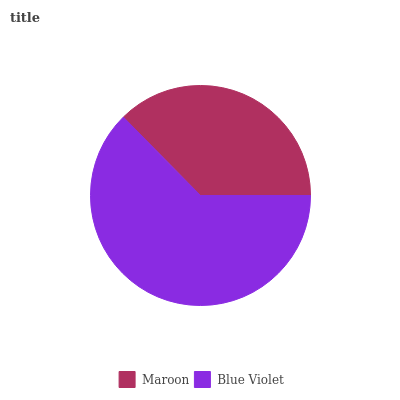Is Maroon the minimum?
Answer yes or no. Yes. Is Blue Violet the maximum?
Answer yes or no. Yes. Is Blue Violet the minimum?
Answer yes or no. No. Is Blue Violet greater than Maroon?
Answer yes or no. Yes. Is Maroon less than Blue Violet?
Answer yes or no. Yes. Is Maroon greater than Blue Violet?
Answer yes or no. No. Is Blue Violet less than Maroon?
Answer yes or no. No. Is Blue Violet the high median?
Answer yes or no. Yes. Is Maroon the low median?
Answer yes or no. Yes. Is Maroon the high median?
Answer yes or no. No. Is Blue Violet the low median?
Answer yes or no. No. 